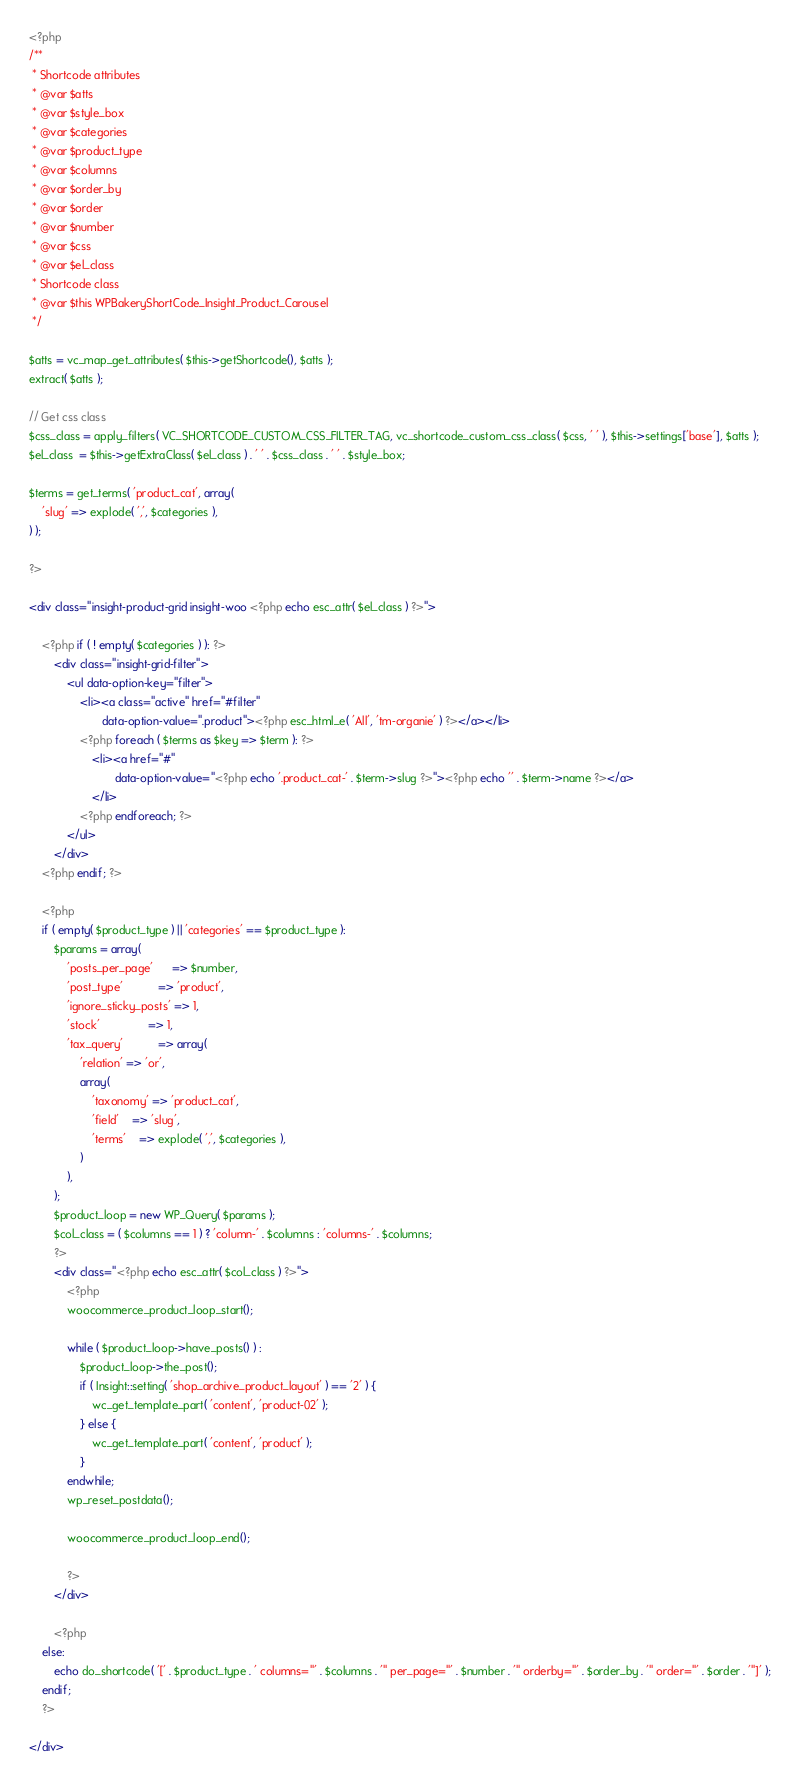Convert code to text. <code><loc_0><loc_0><loc_500><loc_500><_PHP_><?php
/**
 * Shortcode attributes
 * @var $atts
 * @var $style_box
 * @var $categories
 * @var $product_type
 * @var $columns
 * @var $order_by
 * @var $order
 * @var $number
 * @var $css
 * @var $el_class
 * Shortcode class
 * @var $this WPBakeryShortCode_Insight_Product_Carousel
 */

$atts = vc_map_get_attributes( $this->getShortcode(), $atts );
extract( $atts );

// Get css class
$css_class = apply_filters( VC_SHORTCODE_CUSTOM_CSS_FILTER_TAG, vc_shortcode_custom_css_class( $css, ' ' ), $this->settings['base'], $atts );
$el_class  = $this->getExtraClass( $el_class ) . ' ' . $css_class . ' ' . $style_box;

$terms = get_terms( 'product_cat', array(
	'slug' => explode( ',', $categories ),
) );

?>

<div class="insight-product-grid insight-woo <?php echo esc_attr( $el_class ) ?>">

	<?php if ( ! empty( $categories ) ): ?>
		<div class="insight-grid-filter">
			<ul data-option-key="filter">
				<li><a class="active" href="#filter"
				       data-option-value=".product"><?php esc_html_e( 'All', 'tm-organie' ) ?></a></li>
				<?php foreach ( $terms as $key => $term ): ?>
					<li><a href="#"
					       data-option-value="<?php echo '.product_cat-' . $term->slug ?>"><?php echo '' . $term->name ?></a>
					</li>
				<?php endforeach; ?>
			</ul>
		</div>
	<?php endif; ?>

	<?php
	if ( empty( $product_type ) || 'categories' == $product_type ):
		$params = array(
			'posts_per_page'      => $number,
			'post_type'           => 'product',
			'ignore_sticky_posts' => 1,
			'stock'               => 1,
			'tax_query'           => array(
				'relation' => 'or',
				array(
					'taxonomy' => 'product_cat',
					'field'    => 'slug',
					'terms'    => explode( ',', $categories ),
				)
			),
		);
		$product_loop = new WP_Query( $params );
		$col_class = ( $columns == 1 ) ? 'column-' . $columns : 'columns-' . $columns;
		?>
		<div class="<?php echo esc_attr( $col_class ) ?>">
			<?php
			woocommerce_product_loop_start();

			while ( $product_loop->have_posts() ) :
				$product_loop->the_post();
				if ( Insight::setting( 'shop_archive_product_layout' ) == '2' ) {
					wc_get_template_part( 'content', 'product-02' );
				} else {
					wc_get_template_part( 'content', 'product' );
				}
			endwhile;
			wp_reset_postdata();

			woocommerce_product_loop_end();

			?>
		</div>

		<?php
	else:
		echo do_shortcode( '[' . $product_type . ' columns="' . $columns . '" per_page="' . $number . '" orderby="' . $order_by . '" order="' . $order . '"]' );
	endif;
	?>

</div>
</code> 